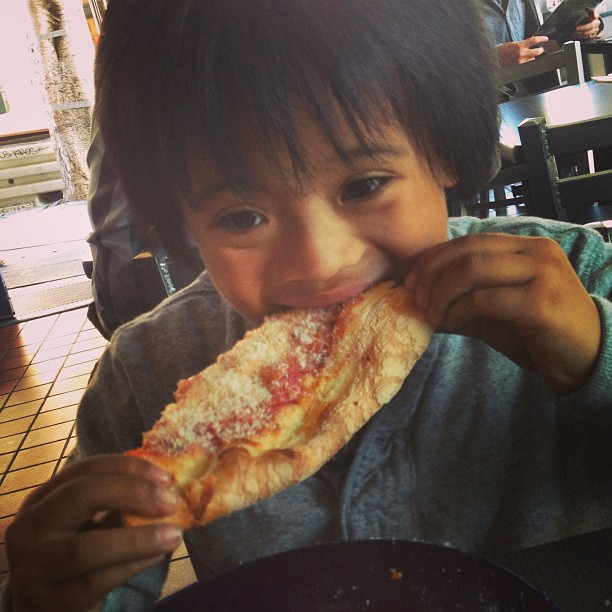<image>How hungry is this child? I don't know how hungry the child is. How hungry is this child? I don't know how hungry the child is. But it seems like the child is very hungry. 